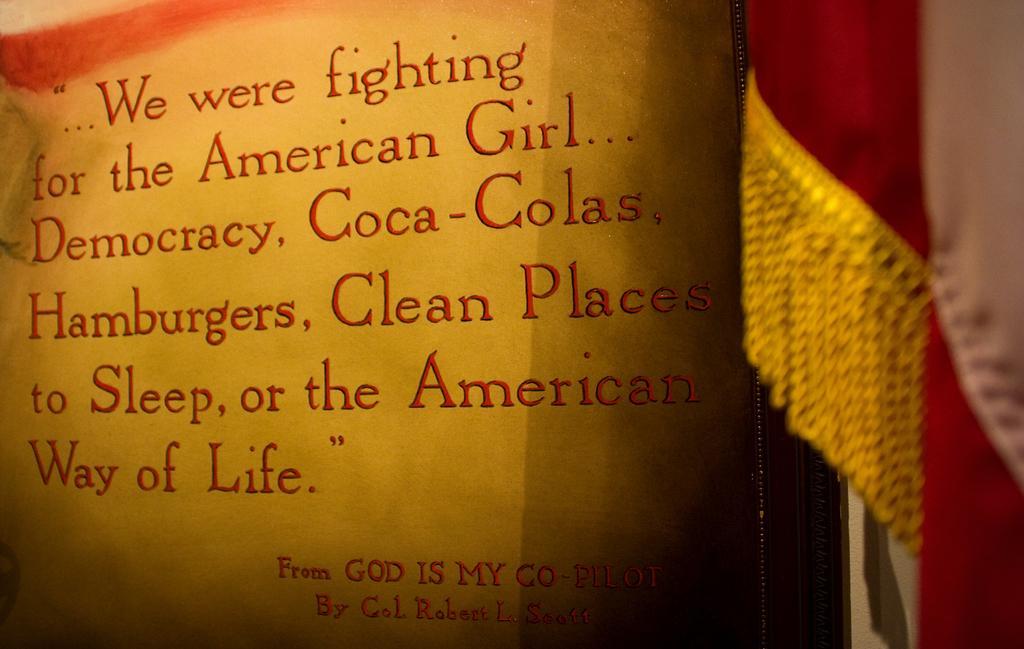Describe this image in one or two sentences. In this image I can see something is written on the red and yellow color cloth. To the side I can see an another cloth and there is a blurred background. 